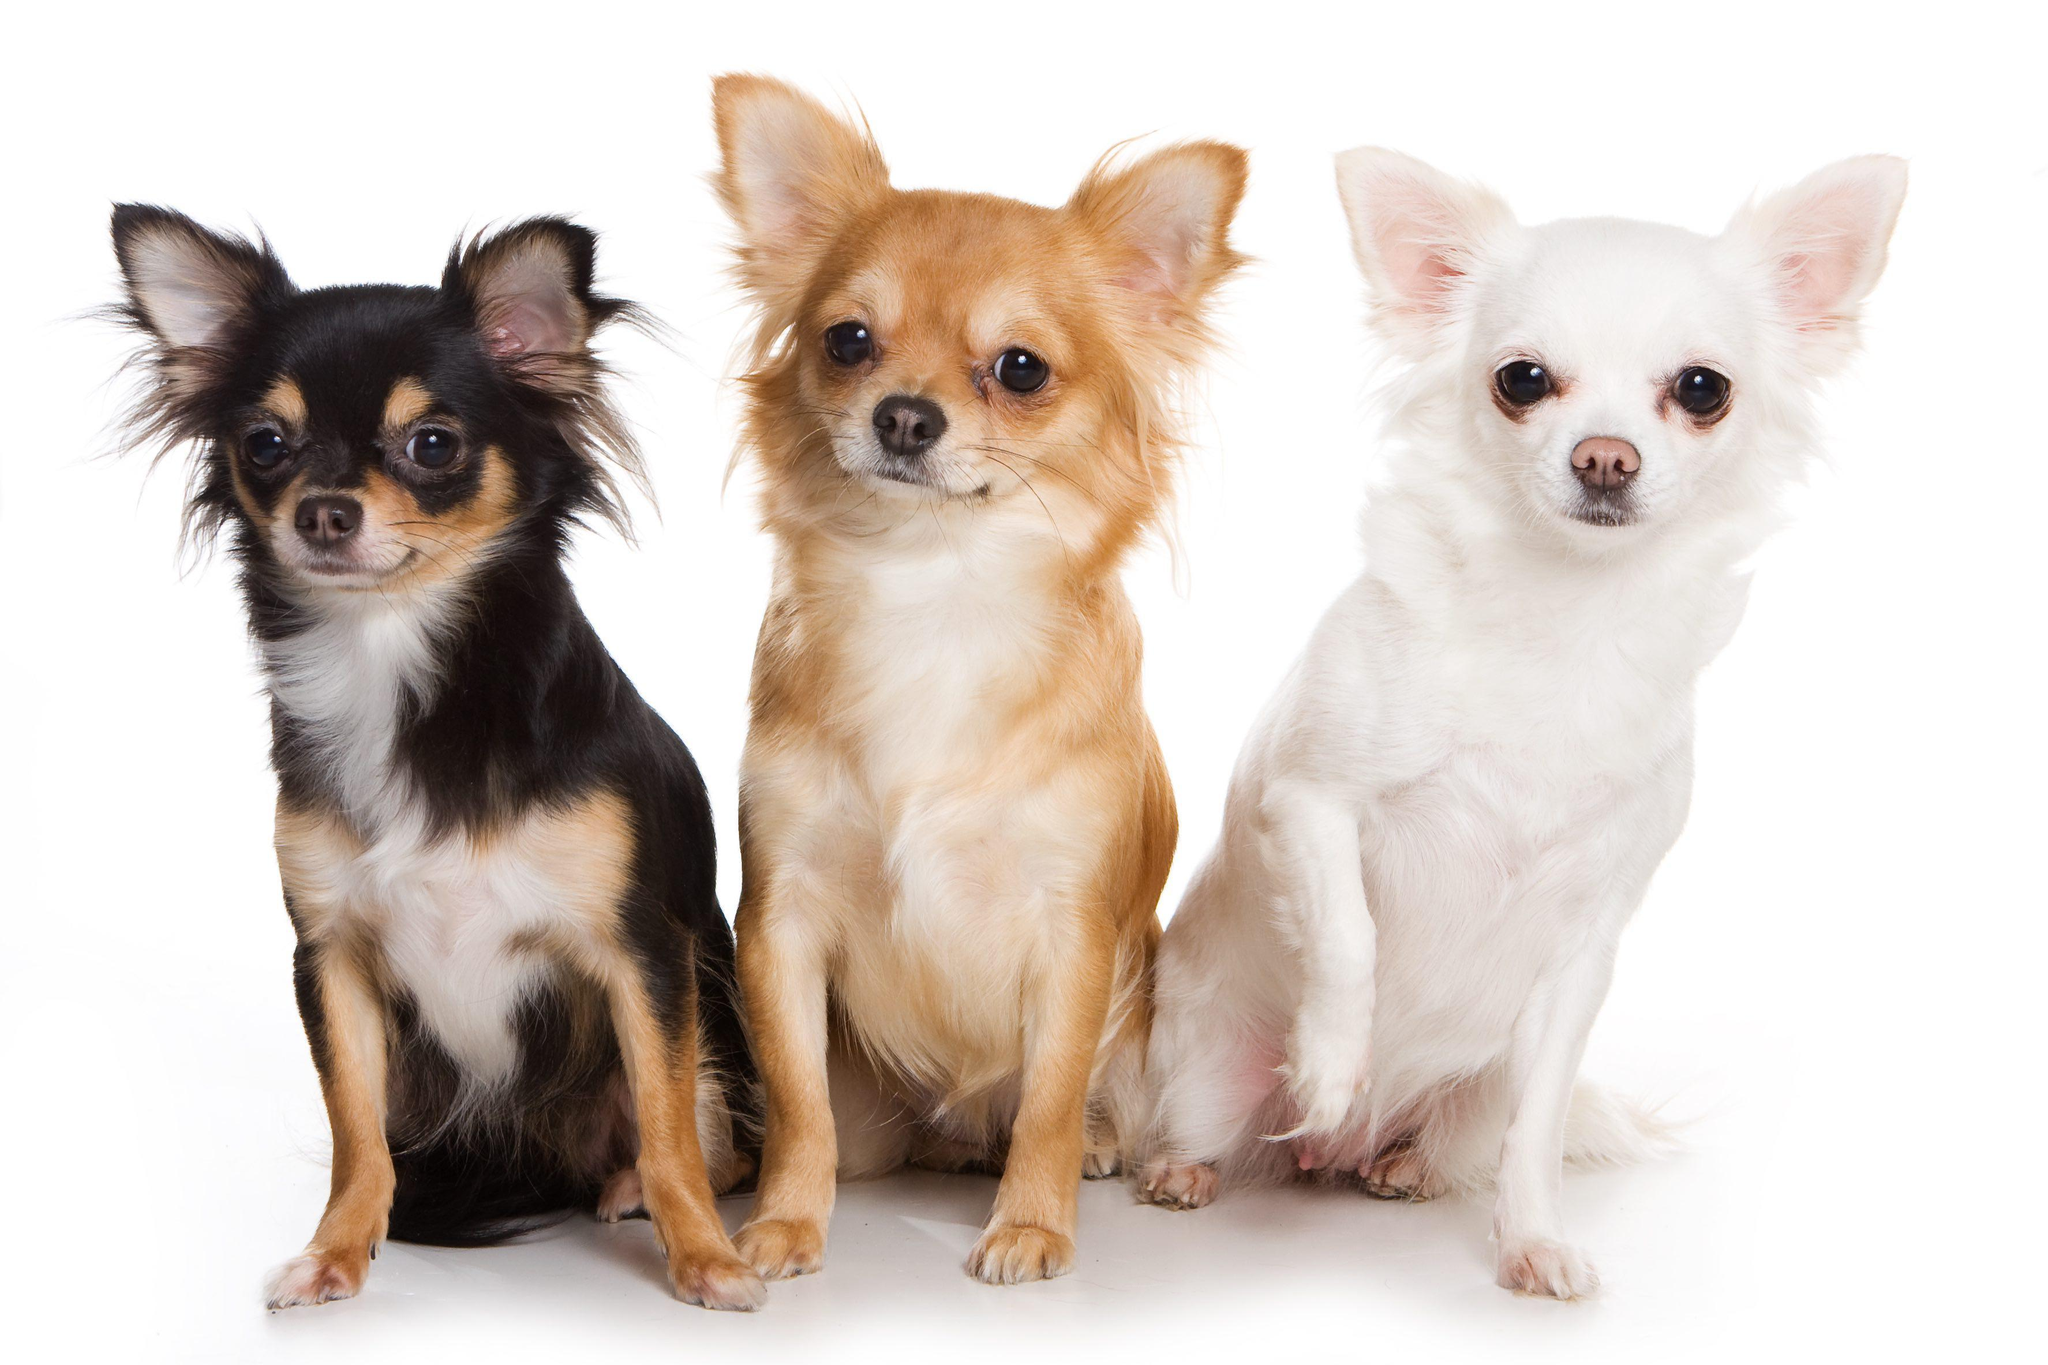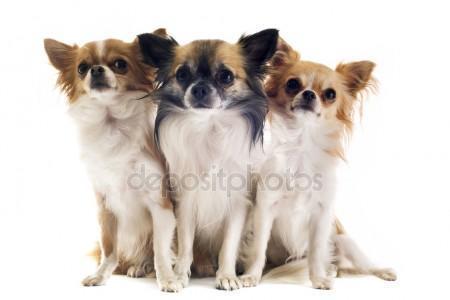The first image is the image on the left, the second image is the image on the right. Examine the images to the left and right. Is the description "There is a single dog in the image on the right." accurate? Answer yes or no. No. The first image is the image on the left, the second image is the image on the right. Assess this claim about the two images: "The right image contains three chihuahua's.". Correct or not? Answer yes or no. Yes. 